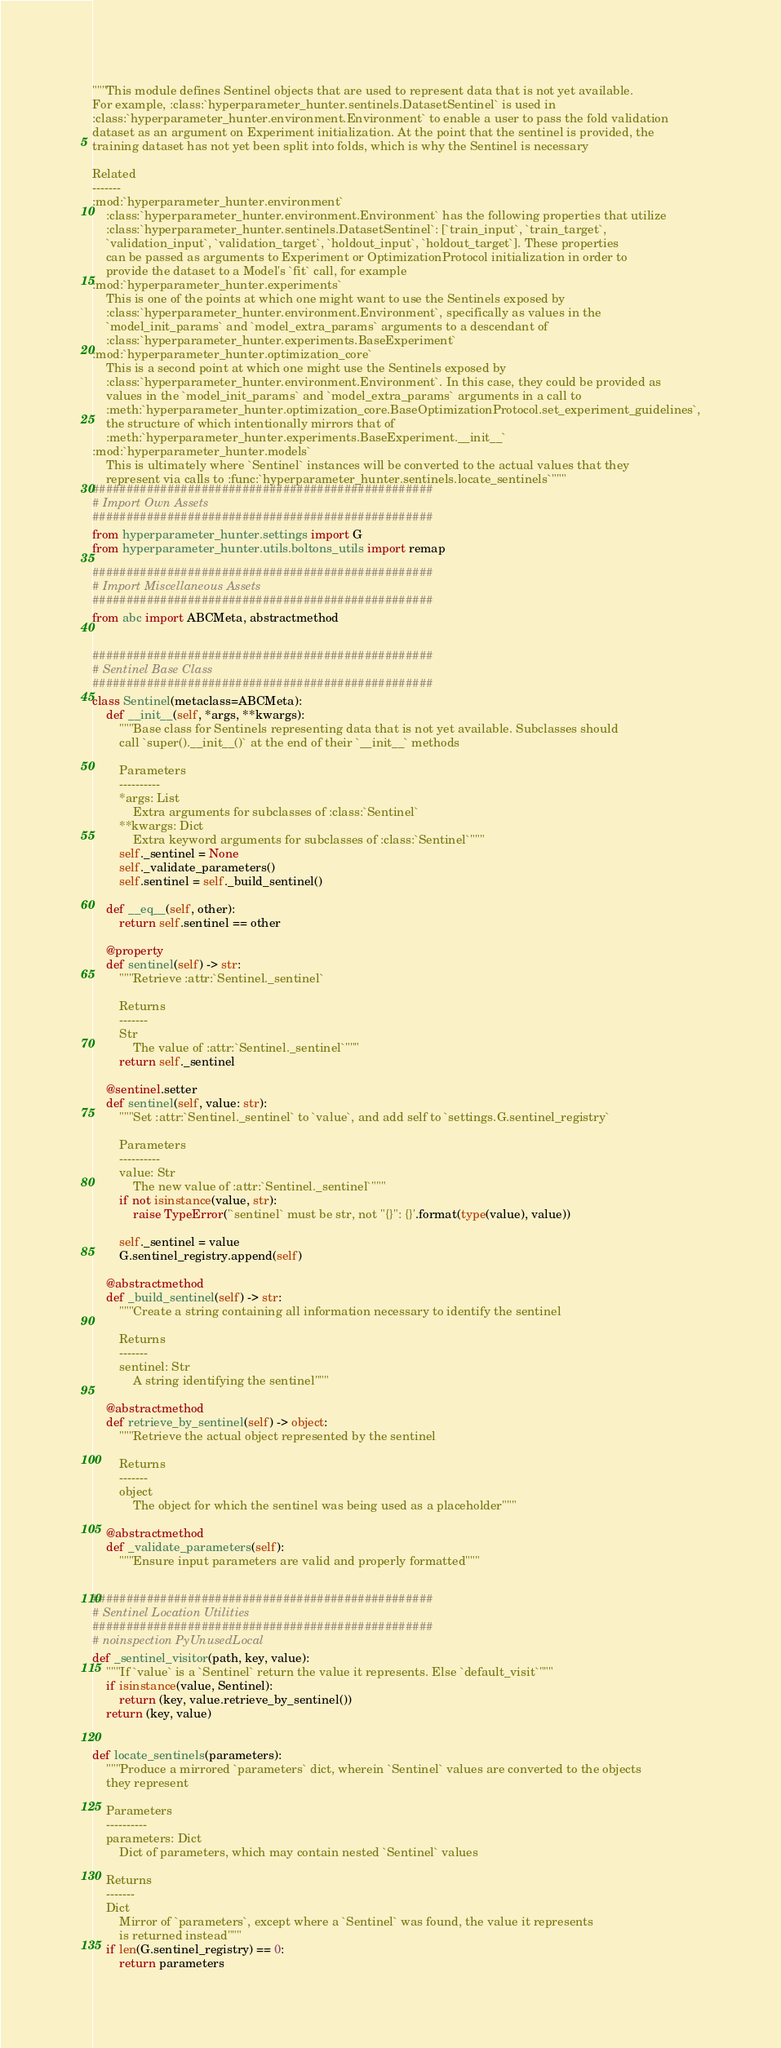Convert code to text. <code><loc_0><loc_0><loc_500><loc_500><_Python_>"""This module defines Sentinel objects that are used to represent data that is not yet available.
For example, :class:`hyperparameter_hunter.sentinels.DatasetSentinel` is used in
:class:`hyperparameter_hunter.environment.Environment` to enable a user to pass the fold validation
dataset as an argument on Experiment initialization. At the point that the sentinel is provided, the
training dataset has not yet been split into folds, which is why the Sentinel is necessary

Related
-------
:mod:`hyperparameter_hunter.environment`
    :class:`hyperparameter_hunter.environment.Environment` has the following properties that utilize
    :class:`hyperparameter_hunter.sentinels.DatasetSentinel`: [`train_input`, `train_target`,
    `validation_input`, `validation_target`, `holdout_input`, `holdout_target`]. These properties
    can be passed as arguments to Experiment or OptimizationProtocol initialization in order to
    provide the dataset to a Model's `fit` call, for example
:mod:`hyperparameter_hunter.experiments`
    This is one of the points at which one might want to use the Sentinels exposed by
    :class:`hyperparameter_hunter.environment.Environment`, specifically as values in the
    `model_init_params` and `model_extra_params` arguments to a descendant of
    :class:`hyperparameter_hunter.experiments.BaseExperiment`
:mod:`hyperparameter_hunter.optimization_core`
    This is a second point at which one might use the Sentinels exposed by
    :class:`hyperparameter_hunter.environment.Environment`. In this case, they could be provided as
    values in the `model_init_params` and `model_extra_params` arguments in a call to
    :meth:`hyperparameter_hunter.optimization_core.BaseOptimizationProtocol.set_experiment_guidelines`,
    the structure of which intentionally mirrors that of
    :meth:`hyperparameter_hunter.experiments.BaseExperiment.__init__`
:mod:`hyperparameter_hunter.models`
    This is ultimately where `Sentinel` instances will be converted to the actual values that they
    represent via calls to :func:`hyperparameter_hunter.sentinels.locate_sentinels`"""
##################################################
# Import Own Assets
##################################################
from hyperparameter_hunter.settings import G
from hyperparameter_hunter.utils.boltons_utils import remap

##################################################
# Import Miscellaneous Assets
##################################################
from abc import ABCMeta, abstractmethod


##################################################
# Sentinel Base Class
##################################################
class Sentinel(metaclass=ABCMeta):
    def __init__(self, *args, **kwargs):
        """Base class for Sentinels representing data that is not yet available. Subclasses should
        call `super().__init__()` at the end of their `__init__` methods

        Parameters
        ----------
        *args: List
            Extra arguments for subclasses of :class:`Sentinel`
        **kwargs: Dict
            Extra keyword arguments for subclasses of :class:`Sentinel`"""
        self._sentinel = None
        self._validate_parameters()
        self.sentinel = self._build_sentinel()

    def __eq__(self, other):
        return self.sentinel == other

    @property
    def sentinel(self) -> str:
        """Retrieve :attr:`Sentinel._sentinel`

        Returns
        -------
        Str
            The value of :attr:`Sentinel._sentinel`"""
        return self._sentinel

    @sentinel.setter
    def sentinel(self, value: str):
        """Set :attr:`Sentinel._sentinel` to `value`, and add self to `settings.G.sentinel_registry`

        Parameters
        ----------
        value: Str
            The new value of :attr:`Sentinel._sentinel`"""
        if not isinstance(value, str):
            raise TypeError('`sentinel` must be str, not "{}": {}'.format(type(value), value))

        self._sentinel = value
        G.sentinel_registry.append(self)

    @abstractmethod
    def _build_sentinel(self) -> str:
        """Create a string containing all information necessary to identify the sentinel

        Returns
        -------
        sentinel: Str
            A string identifying the sentinel"""

    @abstractmethod
    def retrieve_by_sentinel(self) -> object:
        """Retrieve the actual object represented by the sentinel

        Returns
        -------
        object
            The object for which the sentinel was being used as a placeholder"""

    @abstractmethod
    def _validate_parameters(self):
        """Ensure input parameters are valid and properly formatted"""


##################################################
# Sentinel Location Utilities
##################################################
# noinspection PyUnusedLocal
def _sentinel_visitor(path, key, value):
    """If `value` is a `Sentinel` return the value it represents. Else `default_visit`"""
    if isinstance(value, Sentinel):
        return (key, value.retrieve_by_sentinel())
    return (key, value)


def locate_sentinels(parameters):
    """Produce a mirrored `parameters` dict, wherein `Sentinel` values are converted to the objects
    they represent

    Parameters
    ----------
    parameters: Dict
        Dict of parameters, which may contain nested `Sentinel` values

    Returns
    -------
    Dict
        Mirror of `parameters`, except where a `Sentinel` was found, the value it represents
        is returned instead"""
    if len(G.sentinel_registry) == 0:
        return parameters</code> 